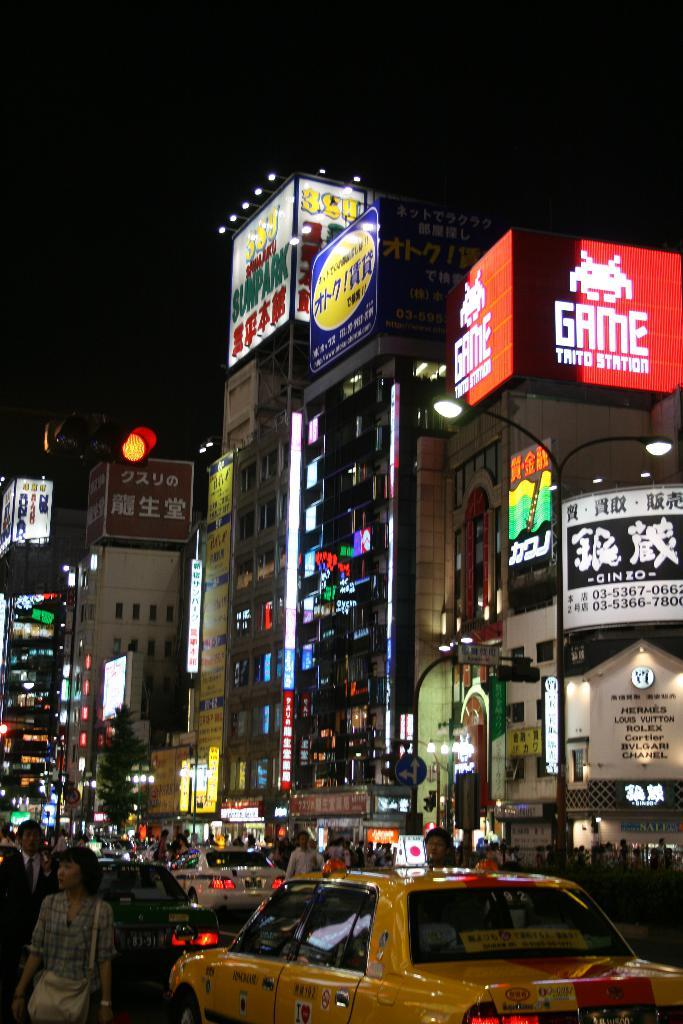<image>
Provide a brief description of the given image. Several buildings in a busy city have Chinese symbols on them, except a large red billboard that says Game Trito Station. 